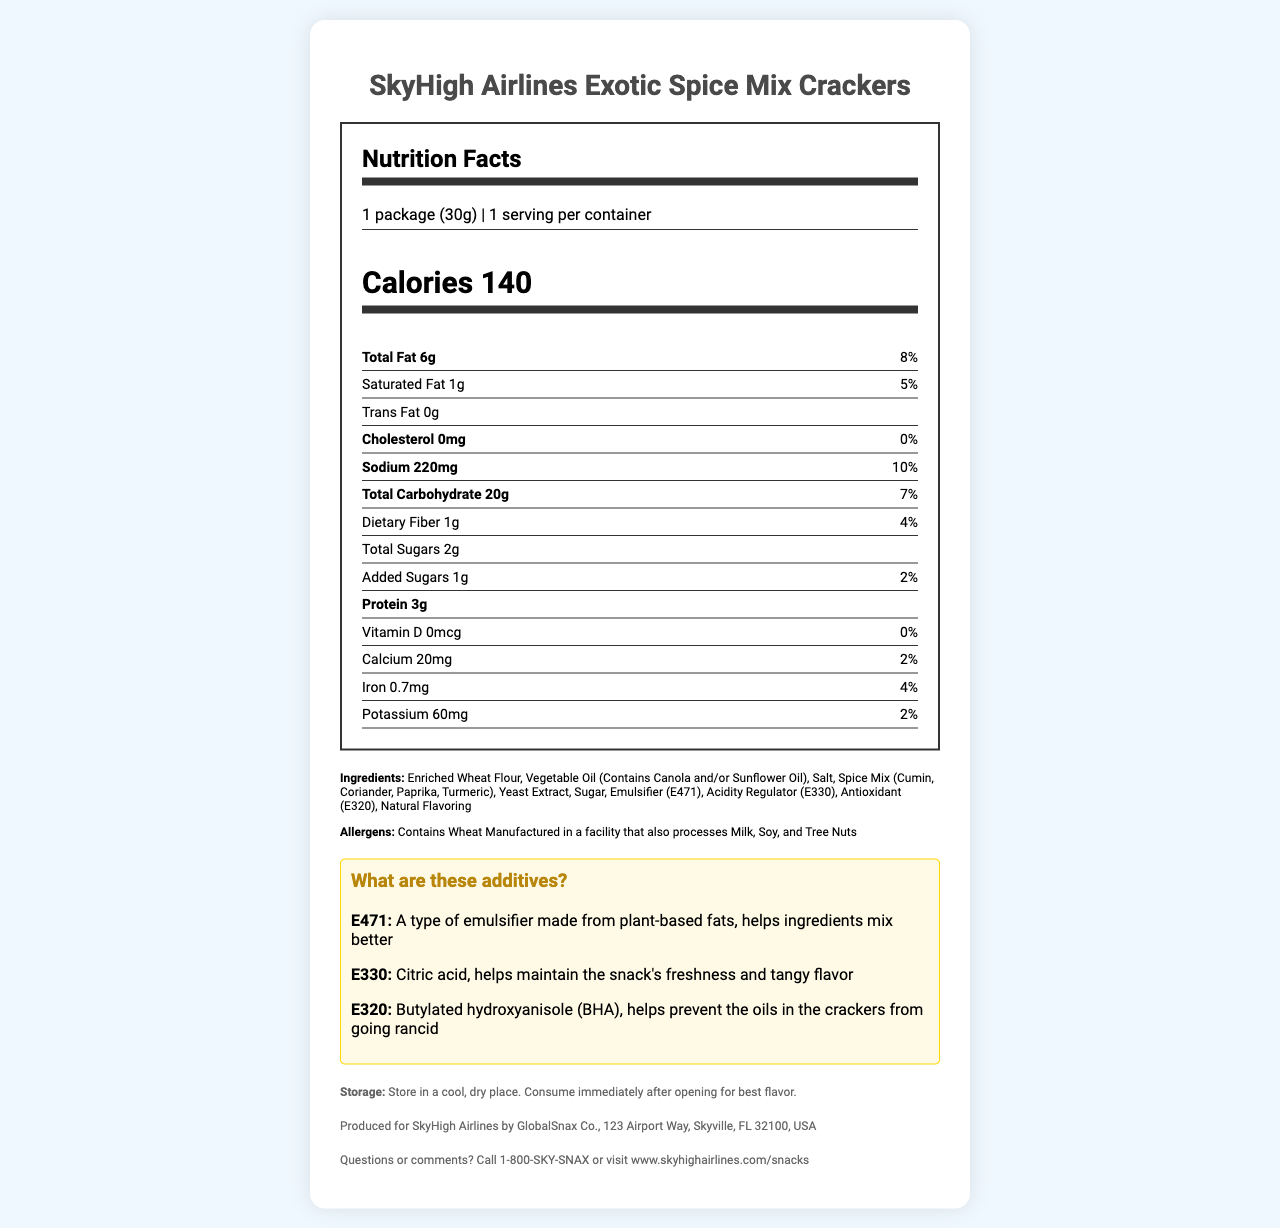what is the serving size for SkyHigh Airlines Exotic Spice Mix Crackers? The serving size is explicitly stated as "1 package (30g)" in the document.
Answer: 1 package (30g) how many calories are in one serving? The document lists the calories as 140 for one serving.
Answer: 140 what percentage of daily value is total fat? The total fat daily value percentage is indicated as 8% in the document.
Answer: 8% what is the amount of sodium in mg? The amount of sodium is given as 220mg in the document.
Answer: 220mg what are the main ingredients in the spice mix? The spice mix is listed in the ingredients section and includes cumin, coriander, paprika, and turmeric.
Answer: Cumin, Coriander, Paprika, Turmeric which of these ingredients is an emulsifier? A. E471 B. E330 C. E320 D. Natural Flavoring E471 is identified as an emulsifier in the confusing additives section of the document.
Answer: A what does E320 refer to? A. Citric Acid B. Butylated Hydroxyanisole C. Emulsifier D. Natural Flavoring E320 is Butylated Hydroxyanisole (BHA), as shown in the explanation of additives.
Answer: B is there any dietary fiber in these crackers? The document states there is 1g of dietary fiber.
Answer: Yes are these crackers suitable for people with wheat allergies? The allergens section mentions that the product contains wheat.
Answer: No how should these crackers be stored? The storage instructions are provided in the document and recommend storing in a cool, dry place and consuming immediately after opening.
Answer: Store in a cool, dry place. Consume immediately after opening for best flavor. describe the main idea of the document. The document gives a comprehensive overview of the nutritional information, ingredients, and additional information related to the snack product.
Answer: The document provides the nutrition facts for SkyHigh Airlines Exotic Spice Mix Crackers, including serving size, calories, nutrient content, ingredients, allergens, confusing additives explanations, storage instructions, manufacturer info, and customer service contact. is there enough protein in one serving to meet 10% of daily value? The document does not provide the daily value percentage for protein, so it cannot be determined if the 3g of protein meets 10% of the daily value.
Answer: Not enough information 